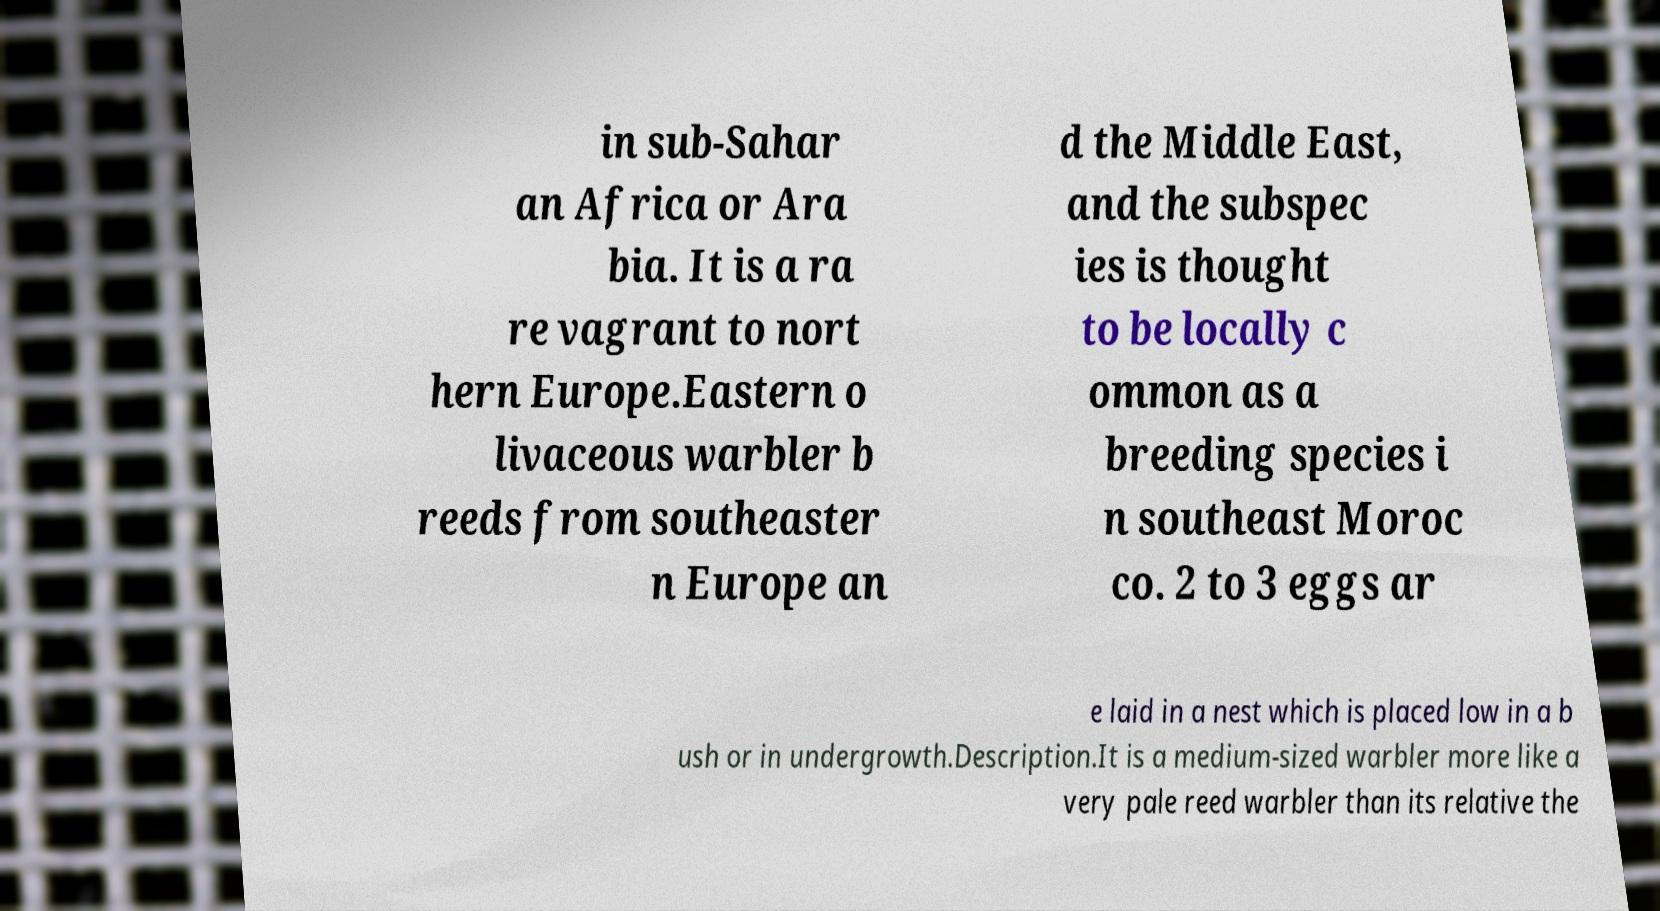Can you accurately transcribe the text from the provided image for me? in sub-Sahar an Africa or Ara bia. It is a ra re vagrant to nort hern Europe.Eastern o livaceous warbler b reeds from southeaster n Europe an d the Middle East, and the subspec ies is thought to be locally c ommon as a breeding species i n southeast Moroc co. 2 to 3 eggs ar e laid in a nest which is placed low in a b ush or in undergrowth.Description.It is a medium-sized warbler more like a very pale reed warbler than its relative the 